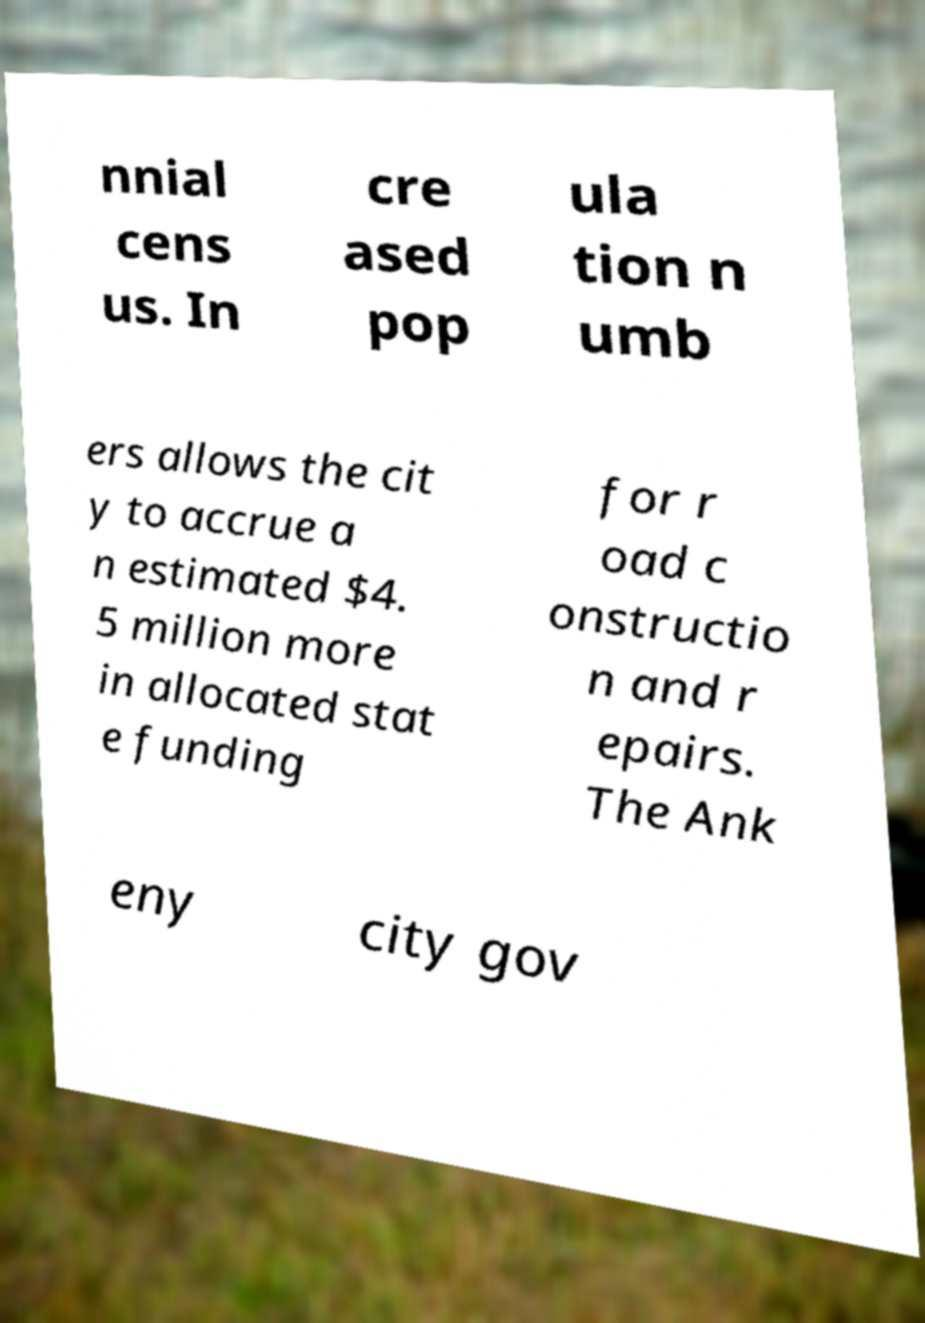There's text embedded in this image that I need extracted. Can you transcribe it verbatim? nnial cens us. In cre ased pop ula tion n umb ers allows the cit y to accrue a n estimated $4. 5 million more in allocated stat e funding for r oad c onstructio n and r epairs. The Ank eny city gov 